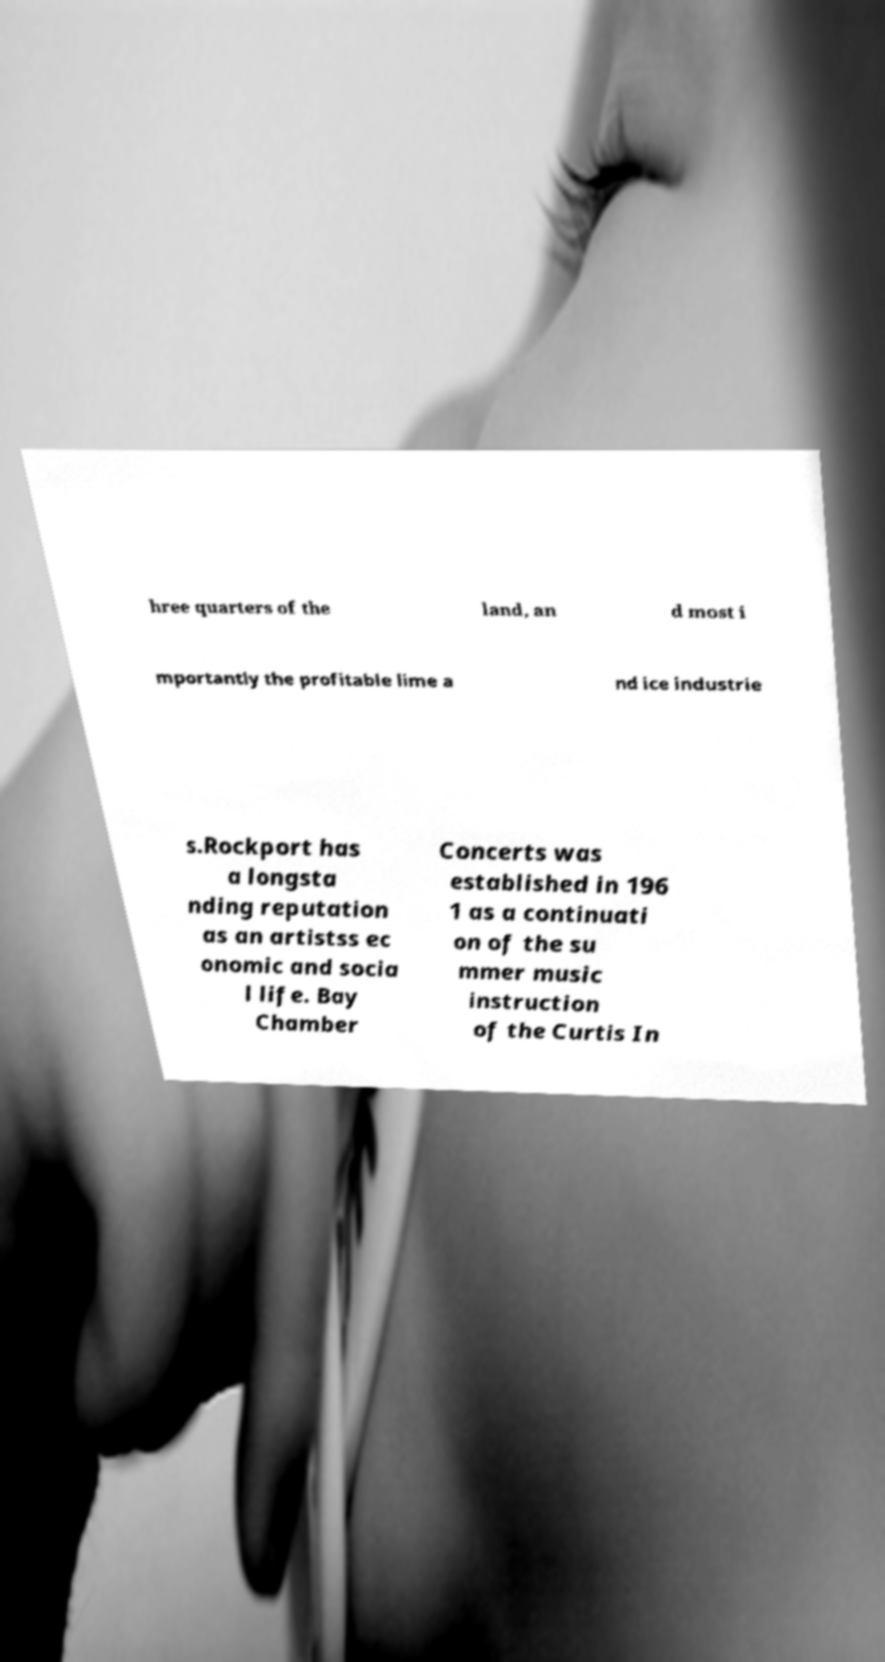I need the written content from this picture converted into text. Can you do that? hree quarters of the land, an d most i mportantly the profitable lime a nd ice industrie s.Rockport has a longsta nding reputation as an artistss ec onomic and socia l life. Bay Chamber Concerts was established in 196 1 as a continuati on of the su mmer music instruction of the Curtis In 